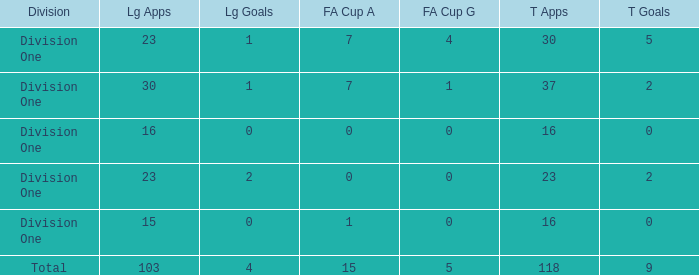The total goals have a FA Cup Apps larger than 1, and a Total Apps of 37, and a League Apps smaller than 30?, what is the total number? 0.0. 